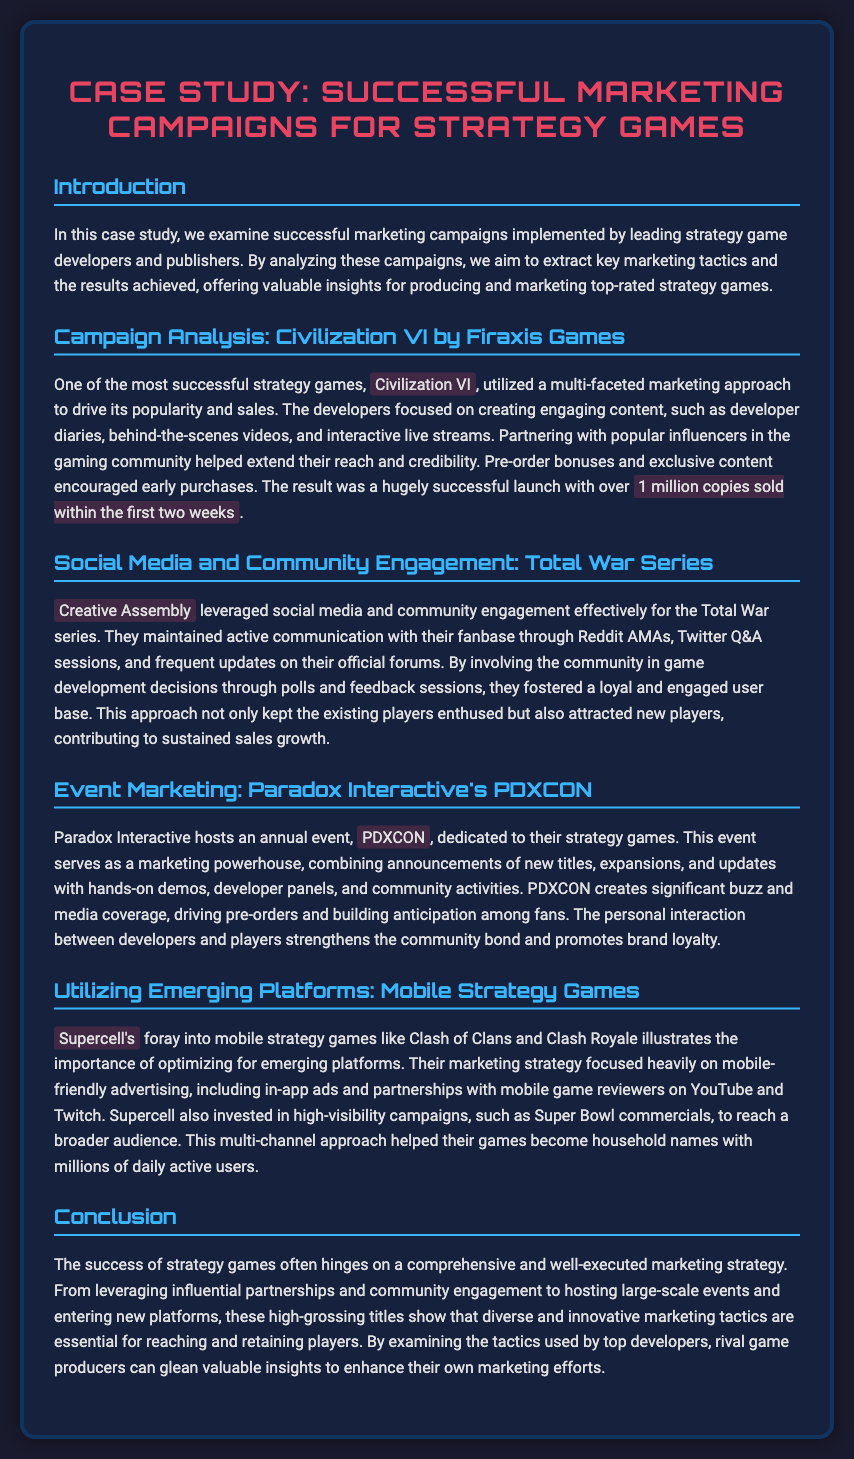What is the title of the case study? The title of the case study is indicated at the top of the document.
Answer: Case Study: Successful Marketing Campaigns for Strategy Games Who developed Civilization VI? The document names the developer of Civilization VI.
Answer: Firaxis Games How many copies of Civilization VI were sold within the first two weeks? The document specifies the sales figures for Civilization VI's launch period.
Answer: 1 million What marketing event does Paradox Interactive host annually? The document mentions a specific event organized by Paradox Interactive.
Answer: PDXCON Which game series employed social media and community engagement effectively? The document identifies a specific game series known for their engagement tactics.
Answer: Total War Series What type of advertising did Supercell focus on for their mobile games? The document details the marketing focus for Supercell's games.
Answer: Mobile-friendly advertising What was a key tactic used for Civilization VI's marketing? The document discusses specific marketing approaches used for Civilization VI.
Answer: Engaging content Why is community interaction important in game marketing? The document explains the benefits of maintaining community interactions for strategy games.
Answer: Strengthens community bond 